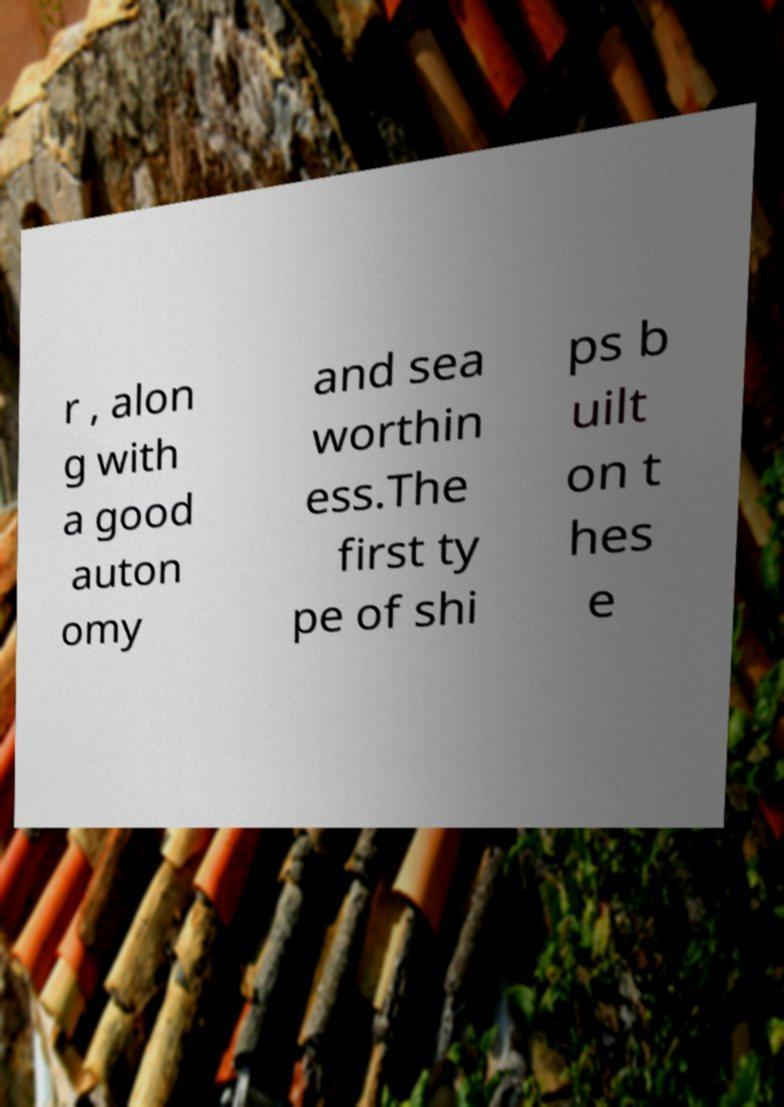Can you accurately transcribe the text from the provided image for me? r , alon g with a good auton omy and sea worthin ess.The first ty pe of shi ps b uilt on t hes e 